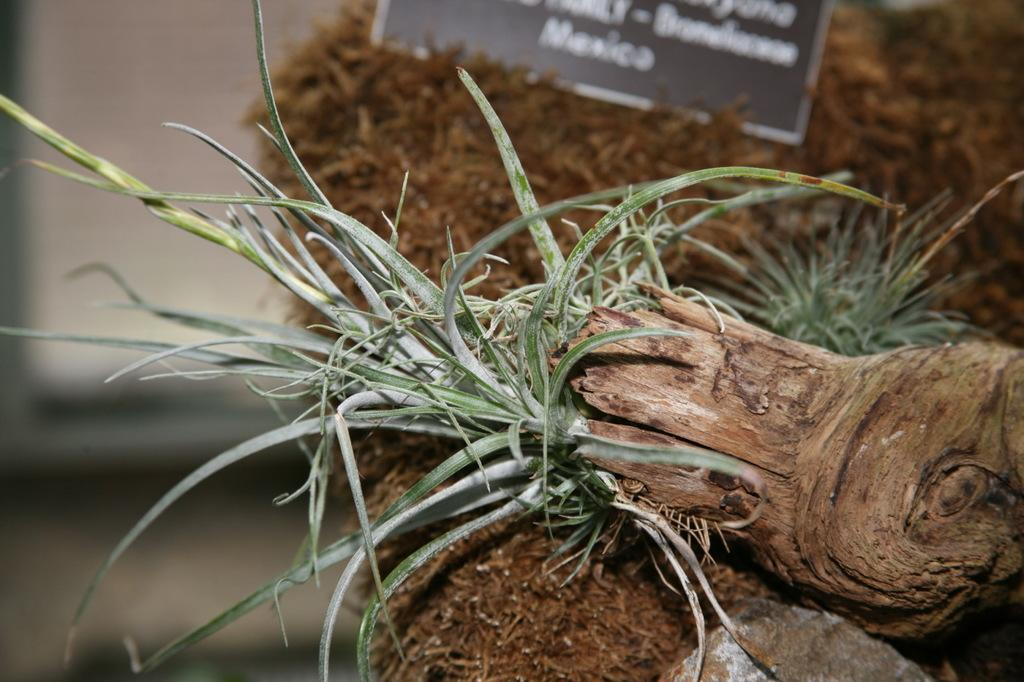What type of vegetation is visible in the image? There is grass in the image. What other object can be seen in the image besides the grass? There is a name board in the image. How many managers are present in the image? There is no mention of managers in the image; it features grass and a name board. What type of furniture is visible in the image? There is no furniture present in the image. Are there any giants visible in the image? There is no mention of giants in the image; it features grass and a name board. 